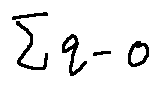Convert formula to latex. <formula><loc_0><loc_0><loc_500><loc_500>\sum q - o</formula> 